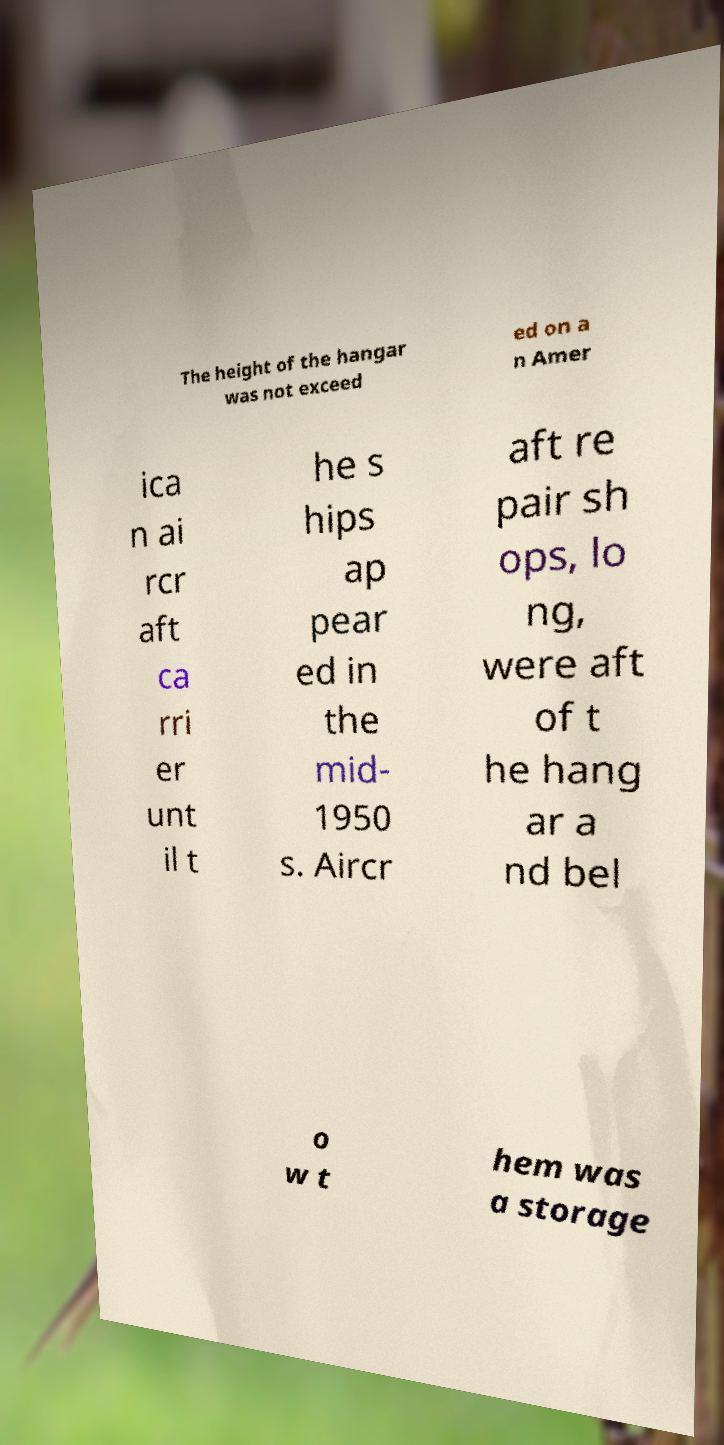For documentation purposes, I need the text within this image transcribed. Could you provide that? The height of the hangar was not exceed ed on a n Amer ica n ai rcr aft ca rri er unt il t he s hips ap pear ed in the mid- 1950 s. Aircr aft re pair sh ops, lo ng, were aft of t he hang ar a nd bel o w t hem was a storage 